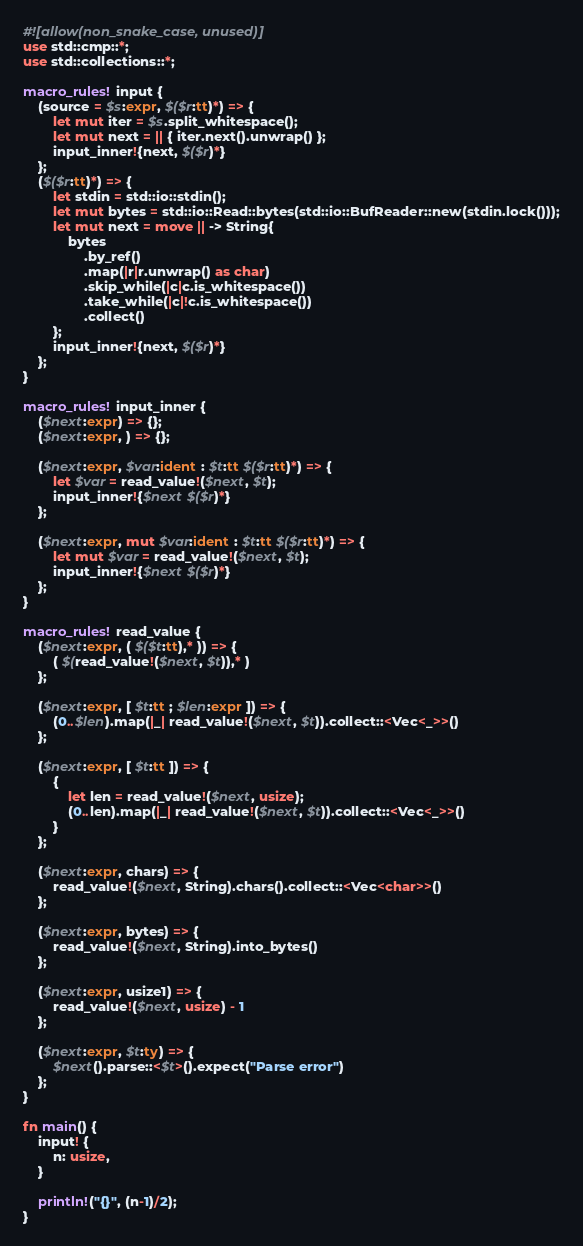Convert code to text. <code><loc_0><loc_0><loc_500><loc_500><_Rust_>#![allow(non_snake_case, unused)]
use std::cmp::*;
use std::collections::*;

macro_rules! input {
    (source = $s:expr, $($r:tt)*) => {
        let mut iter = $s.split_whitespace();
        let mut next = || { iter.next().unwrap() };
        input_inner!{next, $($r)*}
    };
    ($($r:tt)*) => {
        let stdin = std::io::stdin();
        let mut bytes = std::io::Read::bytes(std::io::BufReader::new(stdin.lock()));
        let mut next = move || -> String{
            bytes
                .by_ref()
                .map(|r|r.unwrap() as char)
                .skip_while(|c|c.is_whitespace())
                .take_while(|c|!c.is_whitespace())
                .collect()
        };
        input_inner!{next, $($r)*}
    };
}

macro_rules! input_inner {
    ($next:expr) => {};
    ($next:expr, ) => {};

    ($next:expr, $var:ident : $t:tt $($r:tt)*) => {
        let $var = read_value!($next, $t);
        input_inner!{$next $($r)*}
    };

    ($next:expr, mut $var:ident : $t:tt $($r:tt)*) => {
        let mut $var = read_value!($next, $t);
        input_inner!{$next $($r)*}
    };
}

macro_rules! read_value {
    ($next:expr, ( $($t:tt),* )) => {
        ( $(read_value!($next, $t)),* )
    };

    ($next:expr, [ $t:tt ; $len:expr ]) => {
        (0..$len).map(|_| read_value!($next, $t)).collect::<Vec<_>>()
    };

    ($next:expr, [ $t:tt ]) => {
        {
            let len = read_value!($next, usize);
            (0..len).map(|_| read_value!($next, $t)).collect::<Vec<_>>()
        }
    };

    ($next:expr, chars) => {
        read_value!($next, String).chars().collect::<Vec<char>>()
    };

    ($next:expr, bytes) => {
        read_value!($next, String).into_bytes()
    };

    ($next:expr, usize1) => {
        read_value!($next, usize) - 1
    };

    ($next:expr, $t:ty) => {
        $next().parse::<$t>().expect("Parse error")
    };
}

fn main() {
    input! {
        n: usize,
    }

    println!("{}", (n-1)/2);
}
</code> 